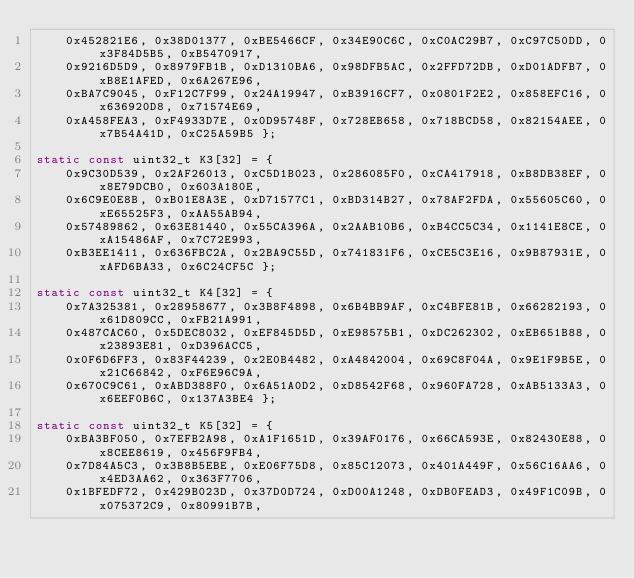Convert code to text. <code><loc_0><loc_0><loc_500><loc_500><_C_>	0x452821E6, 0x38D01377, 0xBE5466CF, 0x34E90C6C, 0xC0AC29B7, 0xC97C50DD, 0x3F84D5B5, 0xB5470917,
	0x9216D5D9, 0x8979FB1B, 0xD1310BA6, 0x98DFB5AC, 0x2FFD72DB, 0xD01ADFB7, 0xB8E1AFED, 0x6A267E96,
	0xBA7C9045, 0xF12C7F99, 0x24A19947, 0xB3916CF7, 0x0801F2E2, 0x858EFC16, 0x636920D8, 0x71574E69,
	0xA458FEA3, 0xF4933D7E, 0x0D95748F, 0x728EB658, 0x718BCD58, 0x82154AEE, 0x7B54A41D, 0xC25A59B5 };

static const uint32_t K3[32] = {
	0x9C30D539, 0x2AF26013, 0xC5D1B023, 0x286085F0, 0xCA417918, 0xB8DB38EF, 0x8E79DCB0, 0x603A180E,
	0x6C9E0E8B, 0xB01E8A3E, 0xD71577C1, 0xBD314B27, 0x78AF2FDA, 0x55605C60, 0xE65525F3, 0xAA55AB94,
	0x57489862, 0x63E81440, 0x55CA396A, 0x2AAB10B6, 0xB4CC5C34, 0x1141E8CE, 0xA15486AF, 0x7C72E993,
	0xB3EE1411, 0x636FBC2A, 0x2BA9C55D, 0x741831F6, 0xCE5C3E16, 0x9B87931E, 0xAFD6BA33, 0x6C24CF5C };

static const uint32_t K4[32] = {
	0x7A325381, 0x28958677, 0x3B8F4898, 0x6B4BB9AF, 0xC4BFE81B, 0x66282193, 0x61D809CC, 0xFB21A991,
	0x487CAC60, 0x5DEC8032, 0xEF845D5D, 0xE98575B1, 0xDC262302, 0xEB651B88, 0x23893E81, 0xD396ACC5,
	0x0F6D6FF3, 0x83F44239, 0x2E0B4482, 0xA4842004, 0x69C8F04A, 0x9E1F9B5E, 0x21C66842, 0xF6E96C9A,
	0x670C9C61, 0xABD388F0, 0x6A51A0D2, 0xD8542F68, 0x960FA728, 0xAB5133A3, 0x6EEF0B6C, 0x137A3BE4 };

static const uint32_t K5[32] = {
	0xBA3BF050, 0x7EFB2A98, 0xA1F1651D, 0x39AF0176, 0x66CA593E, 0x82430E88, 0x8CEE8619, 0x456F9FB4,
	0x7D84A5C3, 0x3B8B5EBE, 0xE06F75D8, 0x85C12073, 0x401A449F, 0x56C16AA6, 0x4ED3AA62, 0x363F7706,
	0x1BFEDF72, 0x429B023D, 0x37D0D724, 0xD00A1248, 0xDB0FEAD3, 0x49F1C09B, 0x075372C9, 0x80991B7B,</code> 